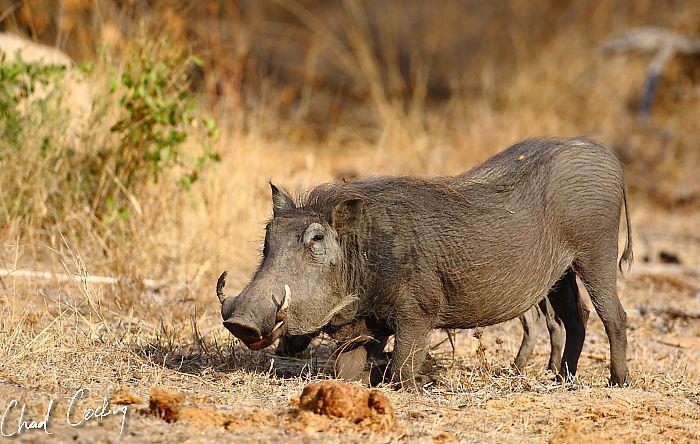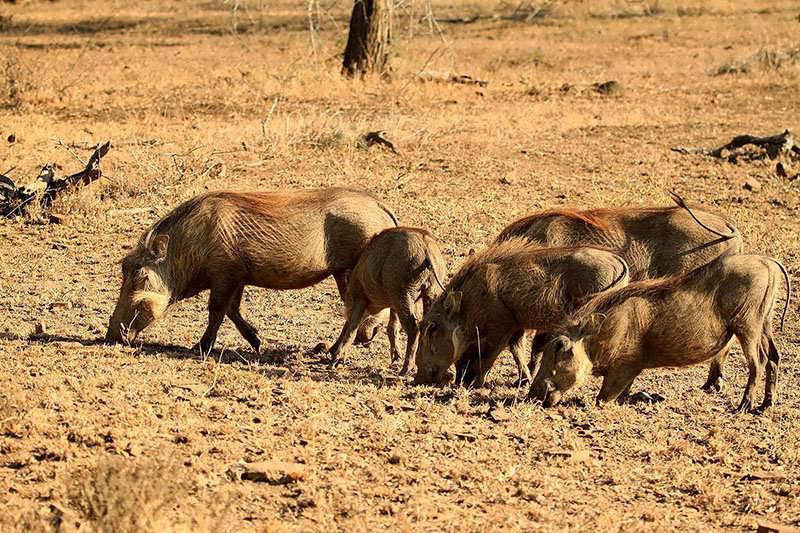The first image is the image on the left, the second image is the image on the right. Considering the images on both sides, is "One image contains no more than three animals." valid? Answer yes or no. Yes. 